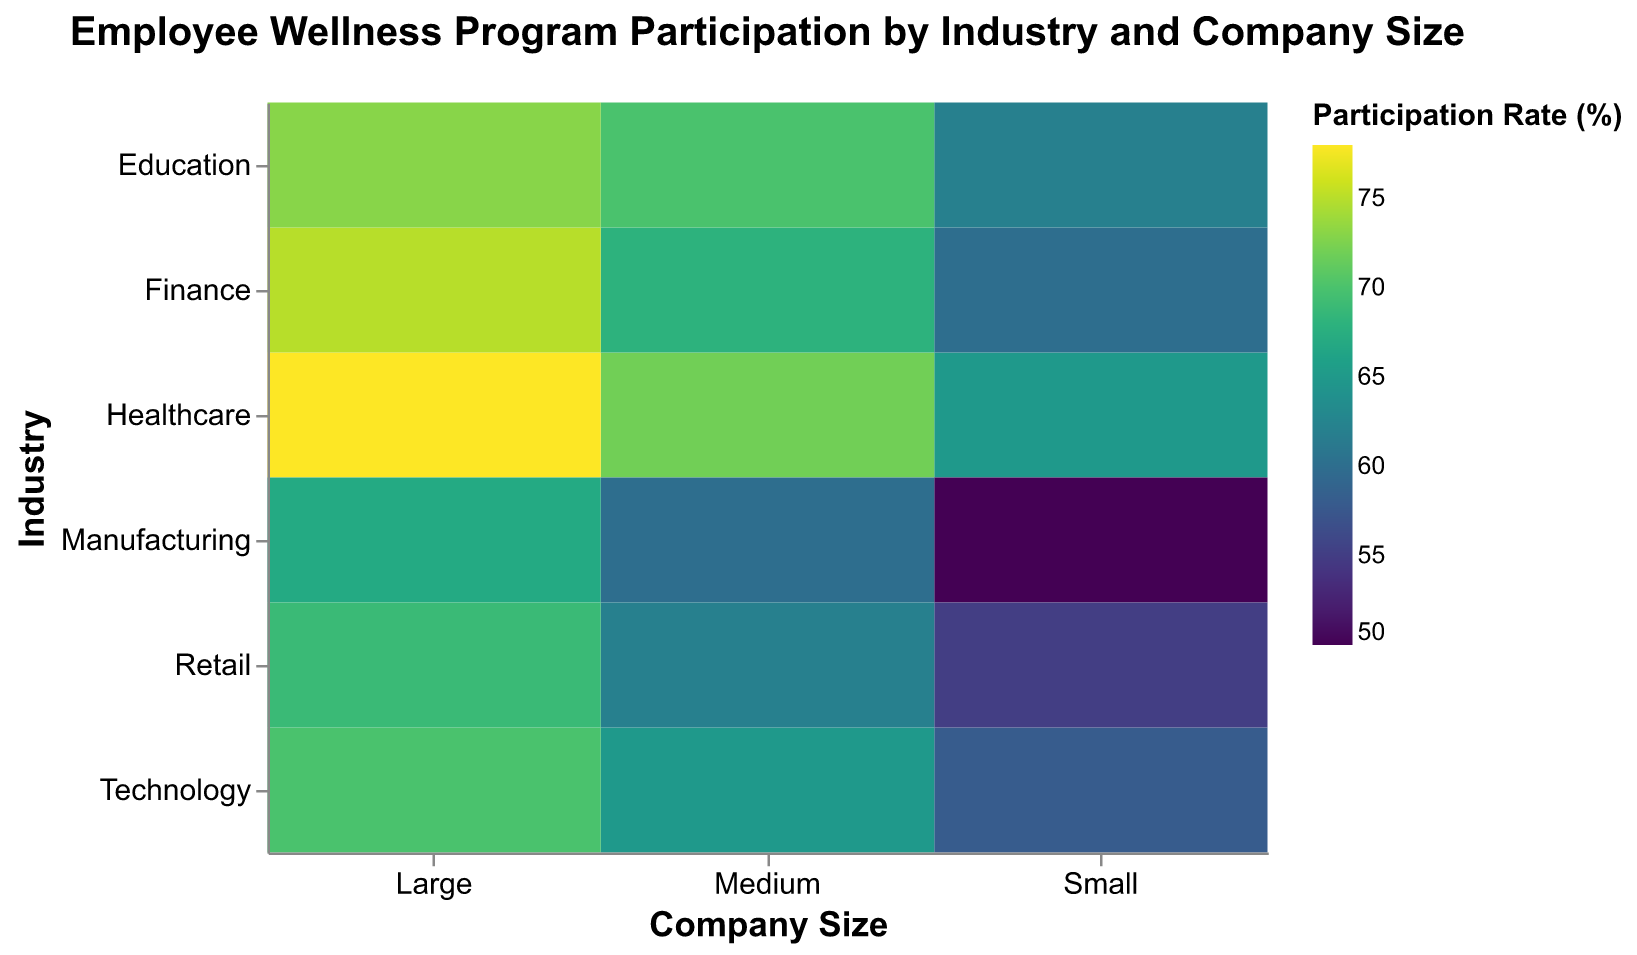What is the title of the heatmap? The title is usually displayed at the top of the heatmap. Here, "Employee Wellness Program Participation by Industry and Company Size" is at the top in bold font.
Answer: Employee Wellness Program Participation by Industry and Company Size Which company size within the healthcare industry has the highest participation rate? By observing the intersections of the Healthcare industry and different company sizes, "Large" has the highest participation rate of 78%.
Answer: Large What is the difference in participation rate between Medium and Small companies in the Retail industry? Locate the Retail industry's row and find the participation rates for Medium (62%) and Small (55%). The difference is calculated as 62 - 55.
Answer: 7% Which industry has the lowest participation rate for Small companies? By scanning the vertical axis (Industries) and looking at the Small column (Company Size), Manufacturing has the lowest participation rate of 50%.
Answer: Manufacturing In which industry do Large companies have the smallest increase in participation rates compared to Small companies? Calculate the difference in participation rates for Large and Small companies within each industry and find the smallest increase. For Manufacturing, it is 67% - 50% = 17%, which is the smallest.
Answer: Manufacturing What is the average participation rate for Medium-sized companies across all industries? Add up the participation rates for Medium-sized companies in each industry (72+65+68+60+62+70) and then divide by the number of industries (6). (72+65+68+60+62+70)/6 = 397/6.
Answer: 66.17% Is there any industry where Medium-sized companies have higher participation rates than Large-sized ones? Compare the participation rates of Medium and Large companies across all industries; none of the industries have Medium-sized companies with higher rates than Large-sized ones.
Answer: No Which industry shows a consistent increase in participation rates from Small to Large companies? For consistency, check if each next size category has a higher value than the previous one within an industry. Healthcare (65, 72, 78) consistently increases from Small to Large companies.
Answer: Healthcare What is the highest participation rate on the heatmap, and which industry and company size does it belong to? Scan through the colors or numbers to find the highest rate. Here, 78% is the highest rate under Healthcare for Large companies.
Answer: 78%, Healthcare, Large Which combination of industry and company size has the closest participation rate to the overall average of all participation rates on the heatmap? First, find the overall average ([65+72+78+58+65+70+60+68+75+50+60+67+55+62+69+62+70+73]/18 = 66.72%). Then, look for the closest participation rate. Technology-Medium has 65%, which is closest to 66.72%.
Answer: Technology, Medium 